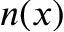<formula> <loc_0><loc_0><loc_500><loc_500>n ( x )</formula> 